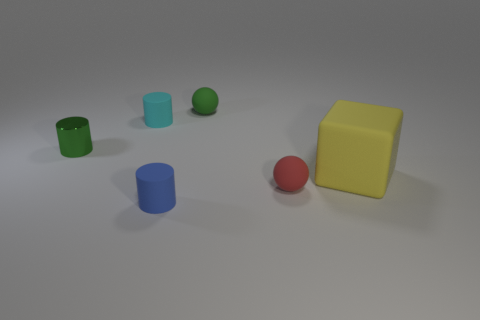Subtract all tiny rubber cylinders. How many cylinders are left? 1 Subtract 1 blocks. How many blocks are left? 0 Subtract all green cylinders. How many cylinders are left? 2 Add 2 tiny blue objects. How many objects exist? 8 Subtract all blue cubes. Subtract all purple cylinders. How many cubes are left? 1 Subtract all red cylinders. How many green cubes are left? 0 Subtract all blue rubber balls. Subtract all small green matte things. How many objects are left? 5 Add 4 tiny rubber balls. How many tiny rubber balls are left? 6 Add 2 small green shiny things. How many small green shiny things exist? 3 Subtract 0 cyan blocks. How many objects are left? 6 